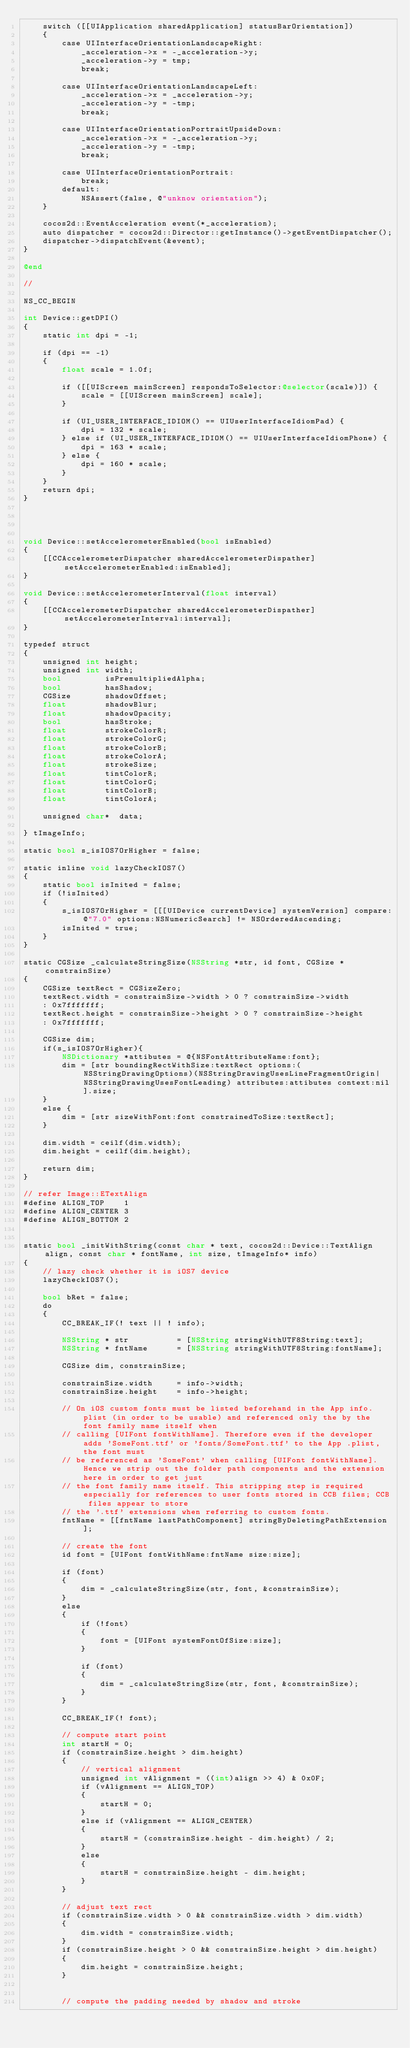Convert code to text. <code><loc_0><loc_0><loc_500><loc_500><_ObjectiveC_>    switch ([[UIApplication sharedApplication] statusBarOrientation])
    {
        case UIInterfaceOrientationLandscapeRight:
            _acceleration->x = -_acceleration->y;
            _acceleration->y = tmp;
            break;
            
        case UIInterfaceOrientationLandscapeLeft:
            _acceleration->x = _acceleration->y;
            _acceleration->y = -tmp;
            break;
            
        case UIInterfaceOrientationPortraitUpsideDown:
            _acceleration->x = -_acceleration->y;
            _acceleration->y = -tmp;
            break;
            
        case UIInterfaceOrientationPortrait:
            break;
        default:
            NSAssert(false, @"unknow orientation");
    }

    cocos2d::EventAcceleration event(*_acceleration);
    auto dispatcher = cocos2d::Director::getInstance()->getEventDispatcher();
    dispatcher->dispatchEvent(&event);
}

@end

//

NS_CC_BEGIN

int Device::getDPI()
{
    static int dpi = -1;

    if (dpi == -1)
    {
        float scale = 1.0f;
        
        if ([[UIScreen mainScreen] respondsToSelector:@selector(scale)]) {
            scale = [[UIScreen mainScreen] scale];
        }
        
        if (UI_USER_INTERFACE_IDIOM() == UIUserInterfaceIdiomPad) {
            dpi = 132 * scale;
        } else if (UI_USER_INTERFACE_IDIOM() == UIUserInterfaceIdiomPhone) {
            dpi = 163 * scale;
        } else {
            dpi = 160 * scale;
        }
    }
    return dpi;
}




void Device::setAccelerometerEnabled(bool isEnabled)
{
    [[CCAccelerometerDispatcher sharedAccelerometerDispather] setAccelerometerEnabled:isEnabled];
}

void Device::setAccelerometerInterval(float interval)
{
    [[CCAccelerometerDispatcher sharedAccelerometerDispather] setAccelerometerInterval:interval];
}

typedef struct
{
    unsigned int height;
    unsigned int width;
    bool         isPremultipliedAlpha;
    bool         hasShadow;
    CGSize       shadowOffset;
    float        shadowBlur;
    float        shadowOpacity;
    bool         hasStroke;
    float        strokeColorR;
    float        strokeColorG;
    float        strokeColorB;
    float        strokeColorA;
    float        strokeSize;
    float        tintColorR;
    float        tintColorG;
    float        tintColorB;
    float        tintColorA;
    
    unsigned char*  data;
    
} tImageInfo;

static bool s_isIOS7OrHigher = false;

static inline void lazyCheckIOS7()
{
    static bool isInited = false;
    if (!isInited)
    {
        s_isIOS7OrHigher = [[[UIDevice currentDevice] systemVersion] compare:@"7.0" options:NSNumericSearch] != NSOrderedAscending;
        isInited = true;
    }
}

static CGSize _calculateStringSize(NSString *str, id font, CGSize *constrainSize)
{
    CGSize textRect = CGSizeZero;
    textRect.width = constrainSize->width > 0 ? constrainSize->width
    : 0x7fffffff;
    textRect.height = constrainSize->height > 0 ? constrainSize->height
    : 0x7fffffff;
    
    CGSize dim;
    if(s_isIOS7OrHigher){
        NSDictionary *attibutes = @{NSFontAttributeName:font};
        dim = [str boundingRectWithSize:textRect options:(NSStringDrawingOptions)(NSStringDrawingUsesLineFragmentOrigin|NSStringDrawingUsesFontLeading) attributes:attibutes context:nil].size;
    }
    else {
        dim = [str sizeWithFont:font constrainedToSize:textRect];
    }

    dim.width = ceilf(dim.width);
    dim.height = ceilf(dim.height);
    
    return dim;
}

// refer Image::ETextAlign
#define ALIGN_TOP    1
#define ALIGN_CENTER 3
#define ALIGN_BOTTOM 2


static bool _initWithString(const char * text, cocos2d::Device::TextAlign align, const char * fontName, int size, tImageInfo* info)
{
    // lazy check whether it is iOS7 device
    lazyCheckIOS7();
    
    bool bRet = false;
    do
    {
        CC_BREAK_IF(! text || ! info);
        
        NSString * str          = [NSString stringWithUTF8String:text];
        NSString * fntName      = [NSString stringWithUTF8String:fontName];
        
        CGSize dim, constrainSize;
        
        constrainSize.width     = info->width;
        constrainSize.height    = info->height;
        
        // On iOS custom fonts must be listed beforehand in the App info.plist (in order to be usable) and referenced only the by the font family name itself when
        // calling [UIFont fontWithName]. Therefore even if the developer adds 'SomeFont.ttf' or 'fonts/SomeFont.ttf' to the App .plist, the font must
        // be referenced as 'SomeFont' when calling [UIFont fontWithName]. Hence we strip out the folder path components and the extension here in order to get just
        // the font family name itself. This stripping step is required especially for references to user fonts stored in CCB files; CCB files appear to store
        // the '.ttf' extensions when referring to custom fonts.
        fntName = [[fntName lastPathComponent] stringByDeletingPathExtension];
        
        // create the font
        id font = [UIFont fontWithName:fntName size:size];
        
        if (font)
        {
            dim = _calculateStringSize(str, font, &constrainSize);
        }
        else
        {
            if (!font)
            {
                font = [UIFont systemFontOfSize:size];
            }
            
            if (font)
            {
                dim = _calculateStringSize(str, font, &constrainSize);
            }
        }
        
        CC_BREAK_IF(! font);
        
        // compute start point
        int startH = 0;
        if (constrainSize.height > dim.height)
        {
            // vertical alignment
            unsigned int vAlignment = ((int)align >> 4) & 0x0F;
            if (vAlignment == ALIGN_TOP)
            {
                startH = 0;
            }
            else if (vAlignment == ALIGN_CENTER)
            {
                startH = (constrainSize.height - dim.height) / 2;
            }
            else
            {
                startH = constrainSize.height - dim.height;
            }
        }
        
        // adjust text rect
        if (constrainSize.width > 0 && constrainSize.width > dim.width)
        {
            dim.width = constrainSize.width;
        }
        if (constrainSize.height > 0 && constrainSize.height > dim.height)
        {
            dim.height = constrainSize.height;
        }
        
        
        // compute the padding needed by shadow and stroke</code> 